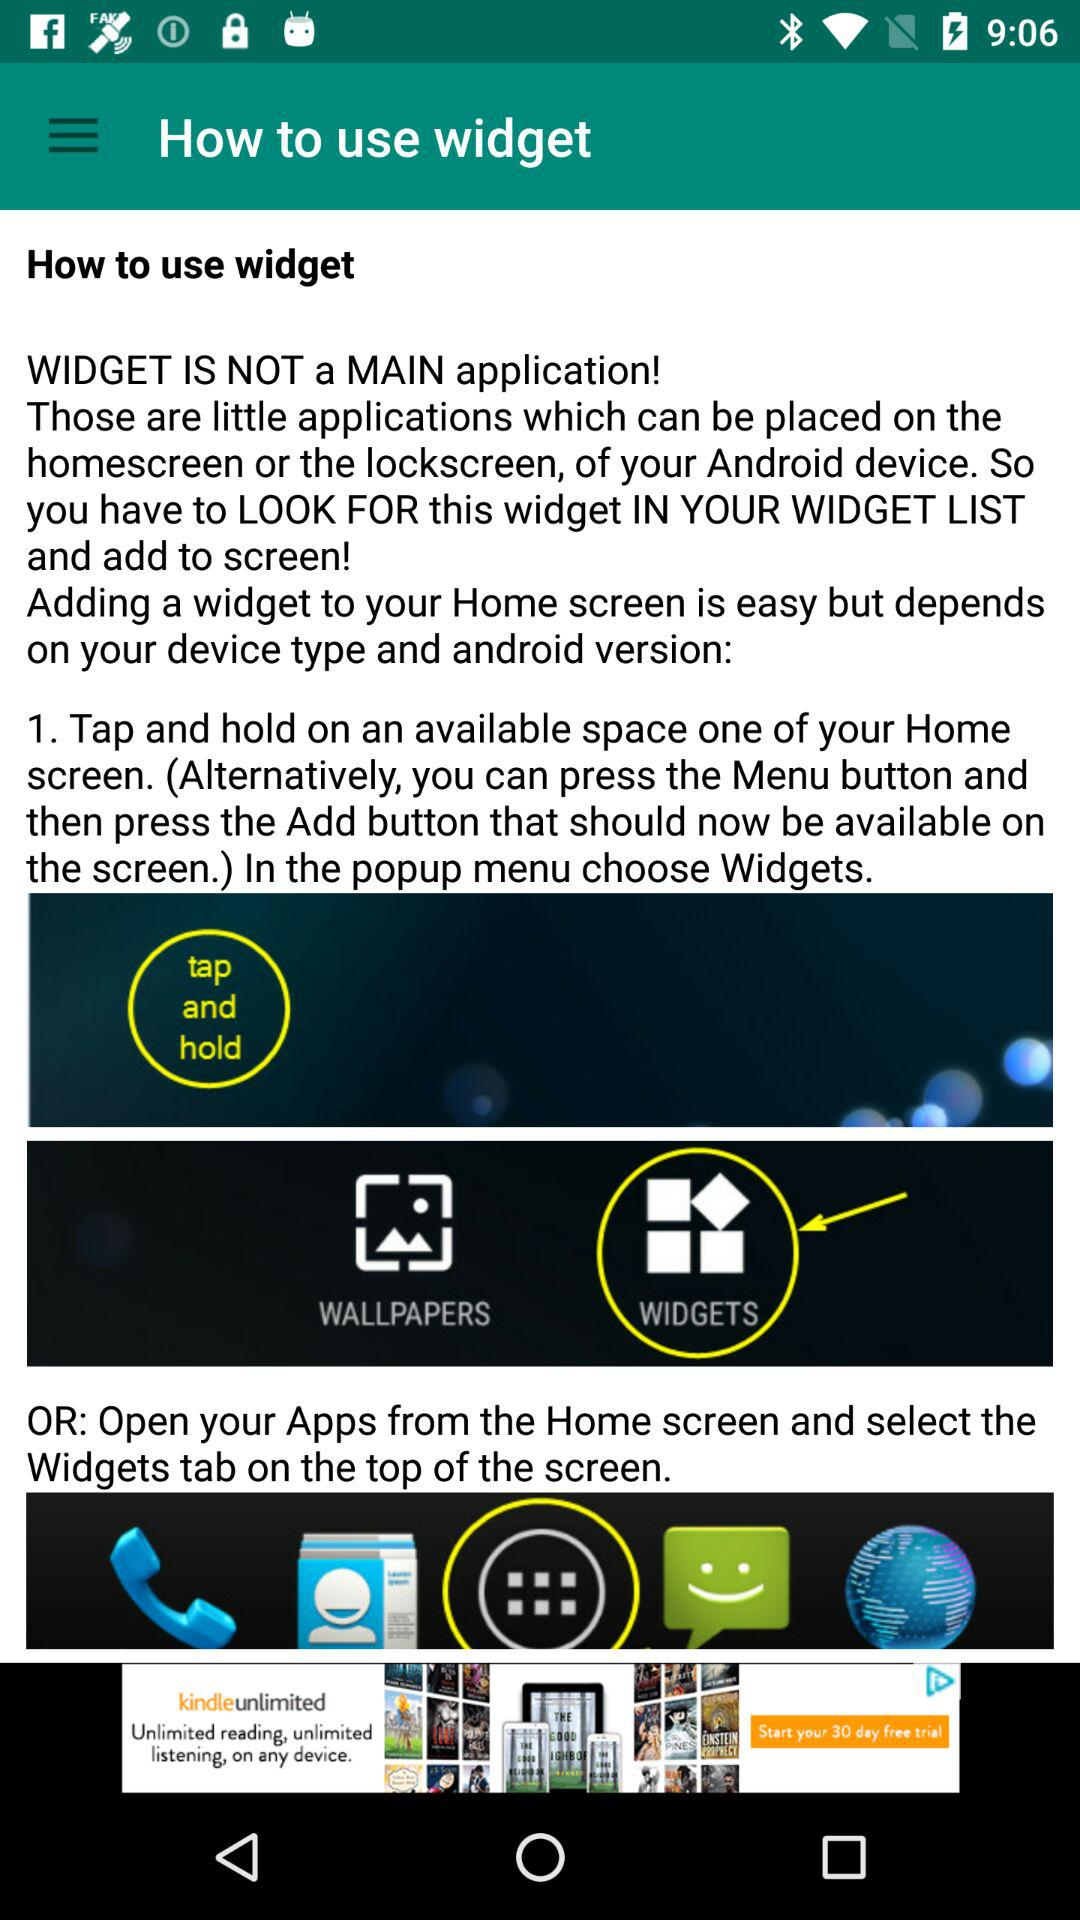How can I add widgets to the home screen? You can add widgets to the home screen by "Tap and hold on an available space one of your Home screen. (Alternatively, you can press the Menu button and then press the Add button that should now be available on the screen.) In the popup menu choose Widgets." or "Open your Apps from the Home screen and select the Widgets tab on the top of the screen". 